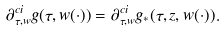Convert formula to latex. <formula><loc_0><loc_0><loc_500><loc_500>\partial ^ { c i } _ { \tau , w } g ( \tau , w ( \cdot ) ) = \partial ^ { c i } _ { \tau , w } g _ { * } ( \tau , z , w ( \cdot ) ) .</formula> 